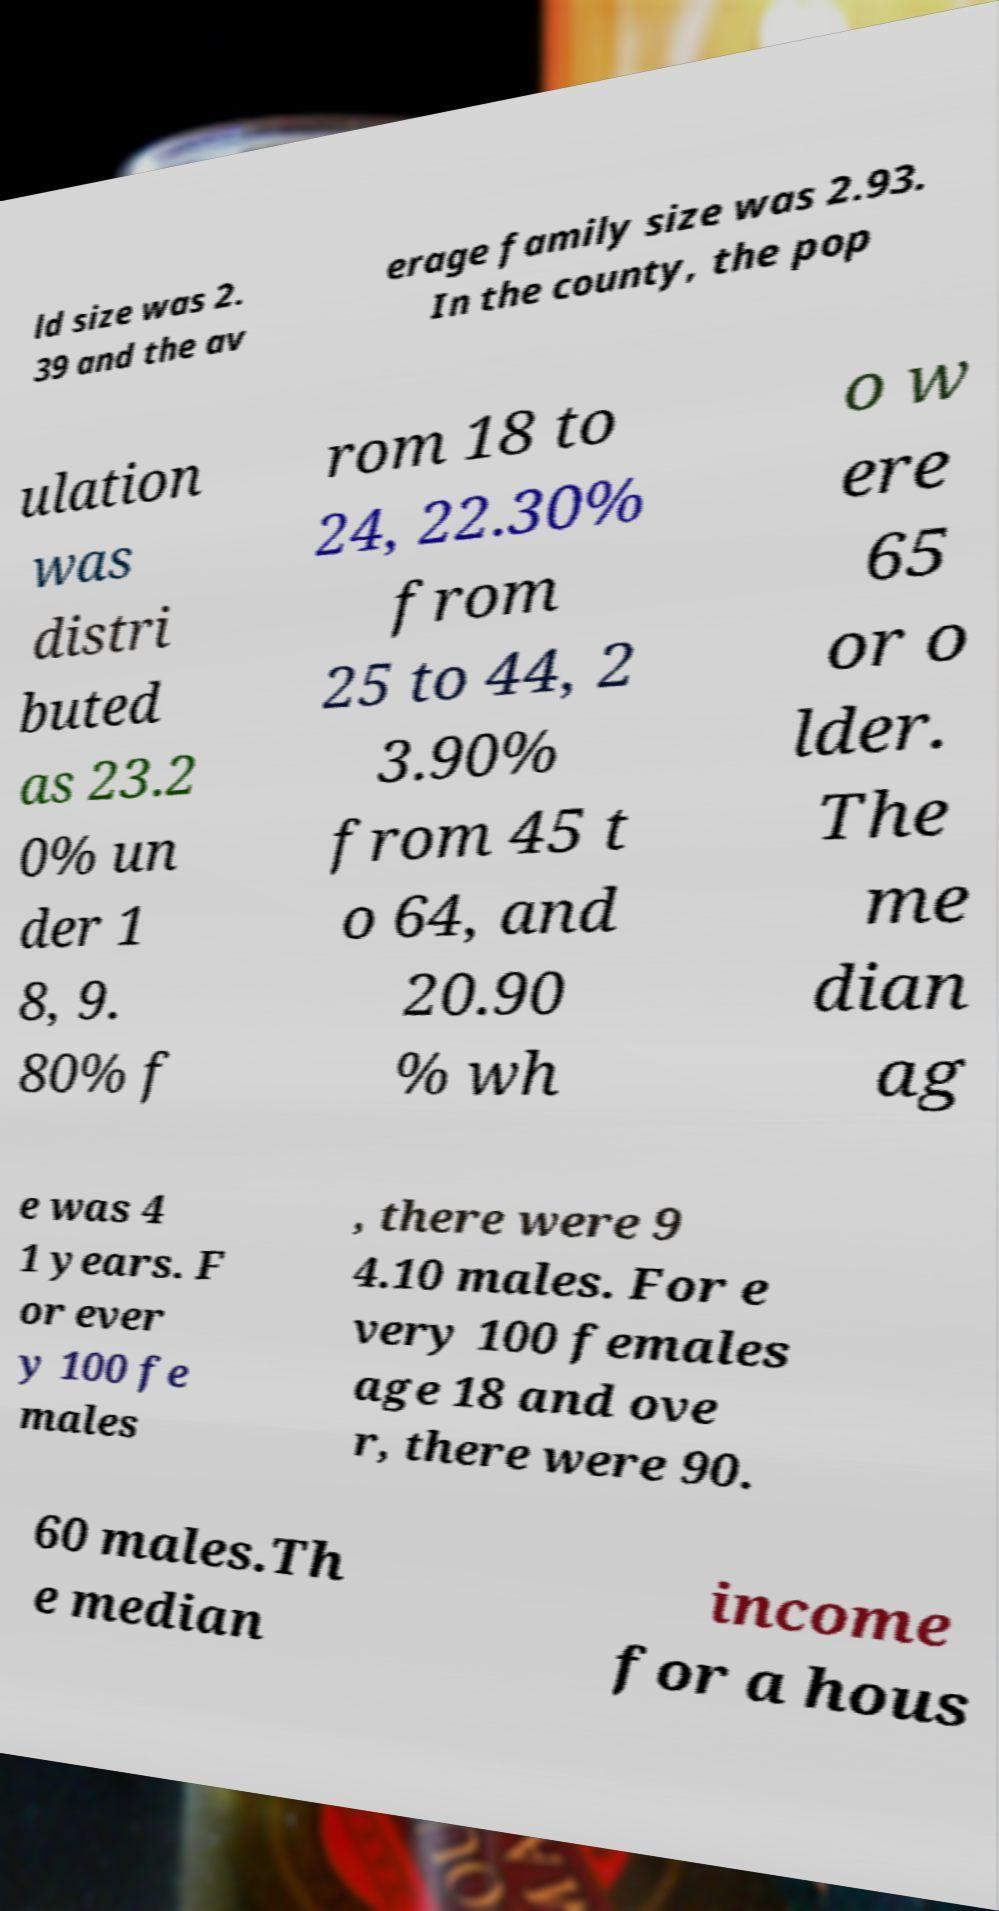Please identify and transcribe the text found in this image. ld size was 2. 39 and the av erage family size was 2.93. In the county, the pop ulation was distri buted as 23.2 0% un der 1 8, 9. 80% f rom 18 to 24, 22.30% from 25 to 44, 2 3.90% from 45 t o 64, and 20.90 % wh o w ere 65 or o lder. The me dian ag e was 4 1 years. F or ever y 100 fe males , there were 9 4.10 males. For e very 100 females age 18 and ove r, there were 90. 60 males.Th e median income for a hous 